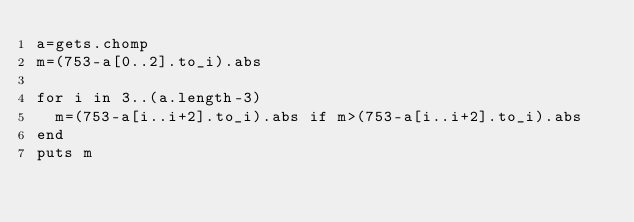Convert code to text. <code><loc_0><loc_0><loc_500><loc_500><_Ruby_>a=gets.chomp
m=(753-a[0..2].to_i).abs

for i in 3..(a.length-3)
  m=(753-a[i..i+2].to_i).abs if m>(753-a[i..i+2].to_i).abs
end
puts m</code> 